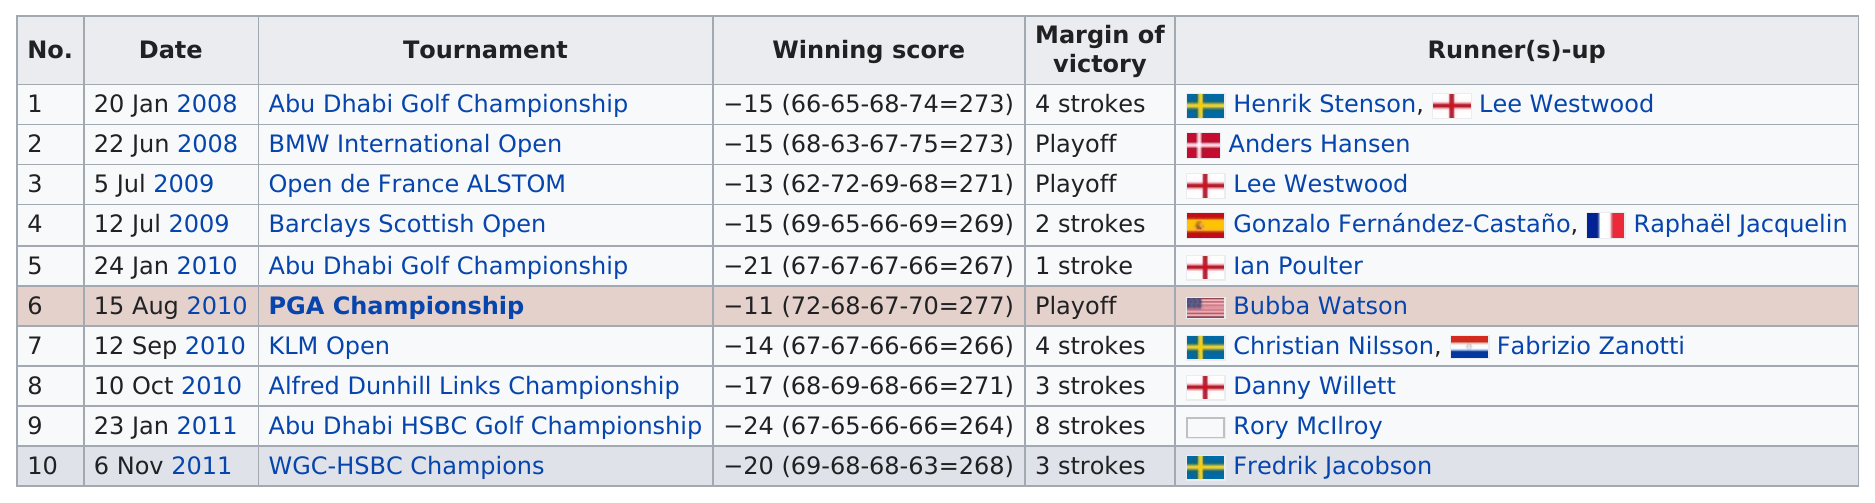Specify some key components in this picture. He has won a total of 5 tournaments by a margin of 3 or more strokes. The player won a tournament by a record-breaking 8 strokes, which was the most strokes he had ever won a tournament by. In the KLM Open, there were 2 fewer strokes than in the Barclays Scottish Open. There were two winning scores that were less than -14. Bubba Watson had the top score in the 2019 PGA Championship. 